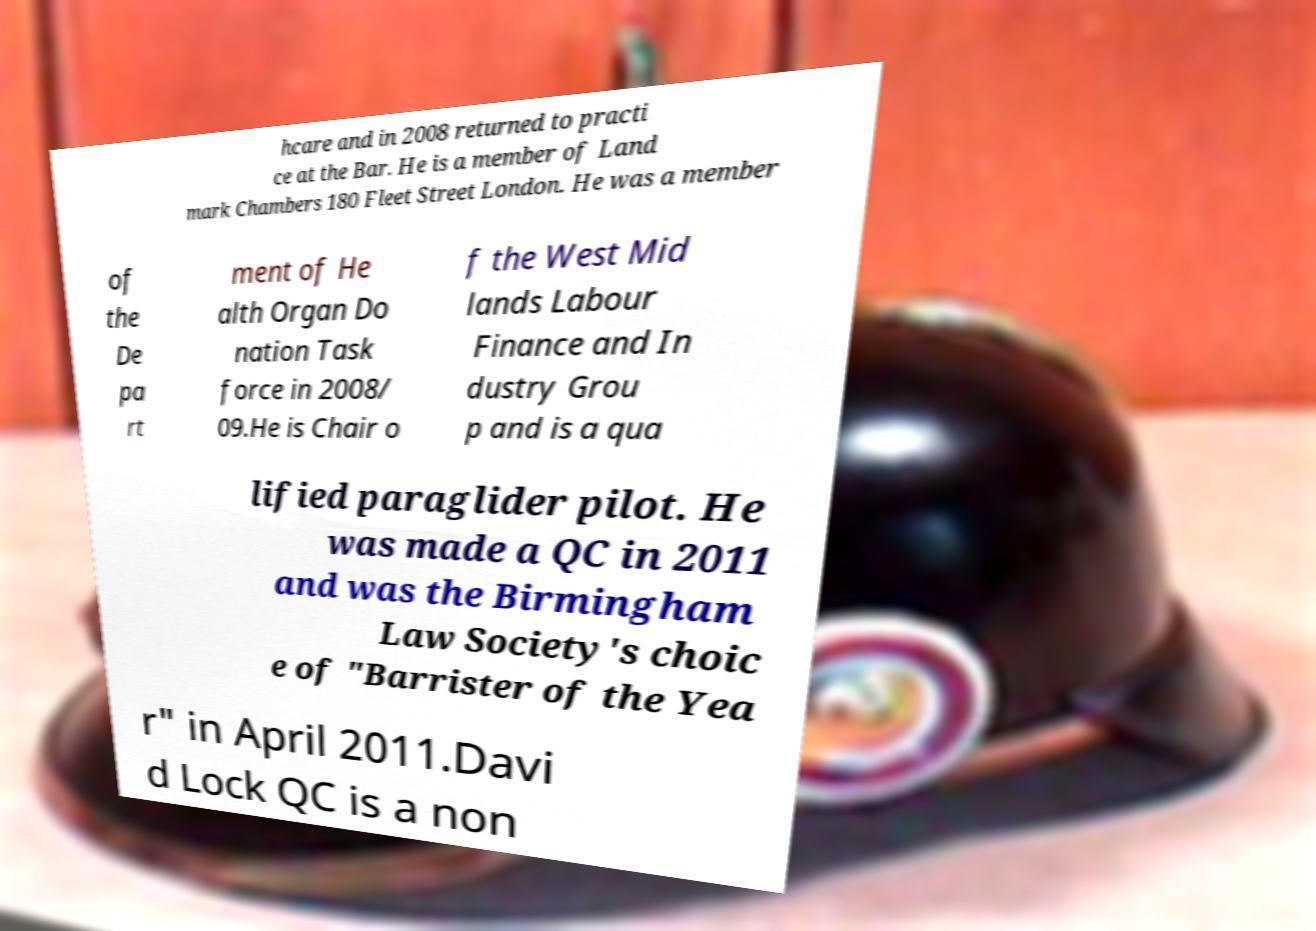Could you extract and type out the text from this image? hcare and in 2008 returned to practi ce at the Bar. He is a member of Land mark Chambers 180 Fleet Street London. He was a member of the De pa rt ment of He alth Organ Do nation Task force in 2008/ 09.He is Chair o f the West Mid lands Labour Finance and In dustry Grou p and is a qua lified paraglider pilot. He was made a QC in 2011 and was the Birmingham Law Society's choic e of "Barrister of the Yea r" in April 2011.Davi d Lock QC is a non 